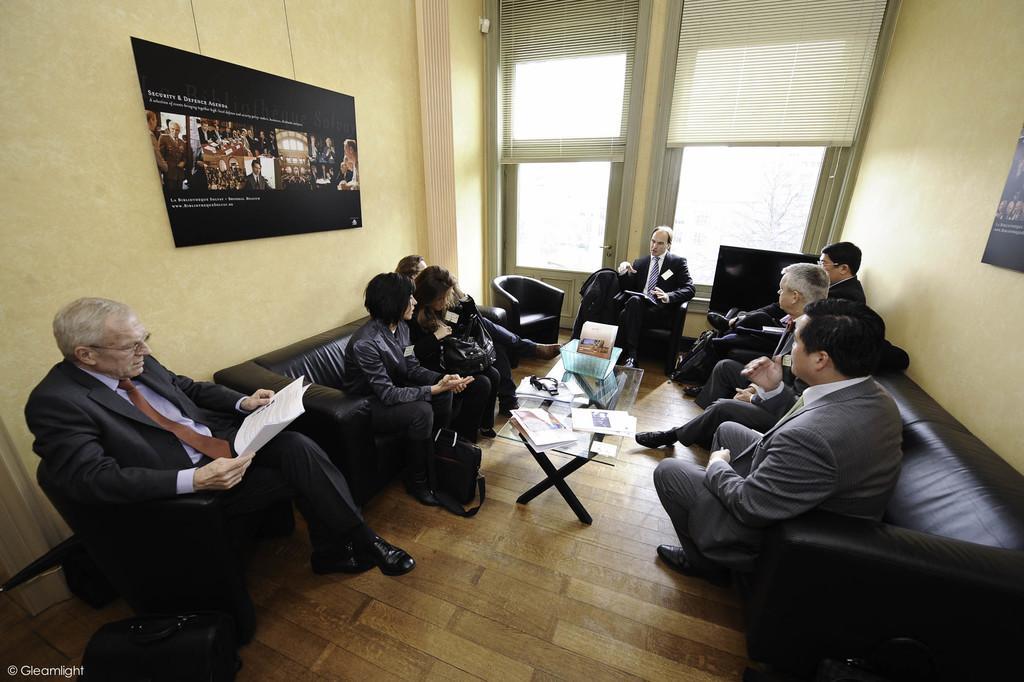Can you describe this image briefly? On the background we can see posts over a wall. These are doors. Here we can see persons sitting on chairs in front of a table and on the table we can see books, paper. This is a floor. At the left side of the picture we can see a man wearing spectacles and holding a paper in his hand. 